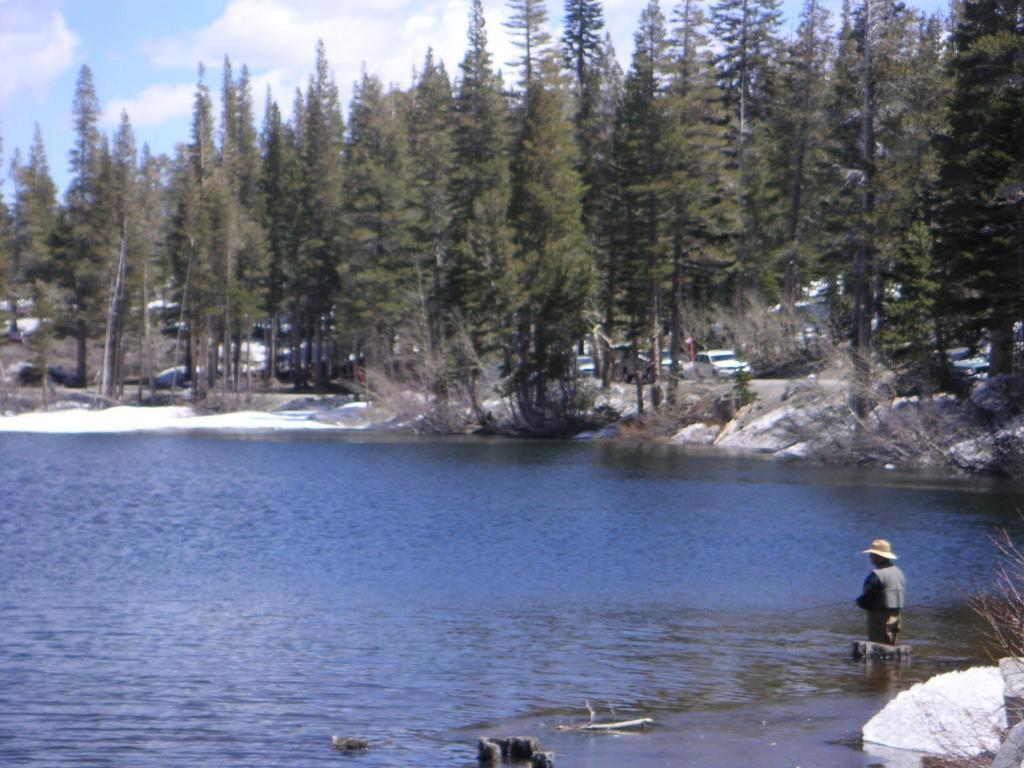Describe this image in one or two sentences. In this picture we can see a person standing in the water. There are a few stones and plants in the bottom right. We can see some objects in the water. There is snow and a few trees are visible from left to right. We can see some vehicles on the road. Sky is blue in color and cloudy. 